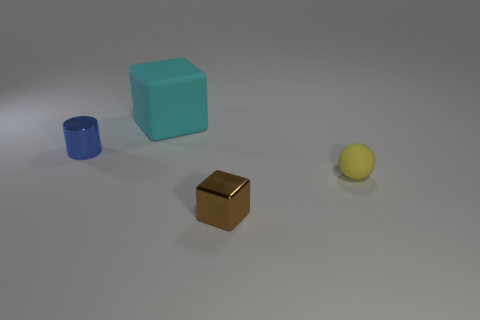Add 1 blue cylinders. How many objects exist? 5 Subtract all spheres. How many objects are left? 3 Subtract all gray blocks. Subtract all green cylinders. How many blocks are left? 2 Subtract all red cylinders. How many cyan blocks are left? 1 Subtract all cubes. Subtract all small brown things. How many objects are left? 1 Add 4 tiny yellow spheres. How many tiny yellow spheres are left? 5 Add 3 blocks. How many blocks exist? 5 Subtract 0 yellow cubes. How many objects are left? 4 